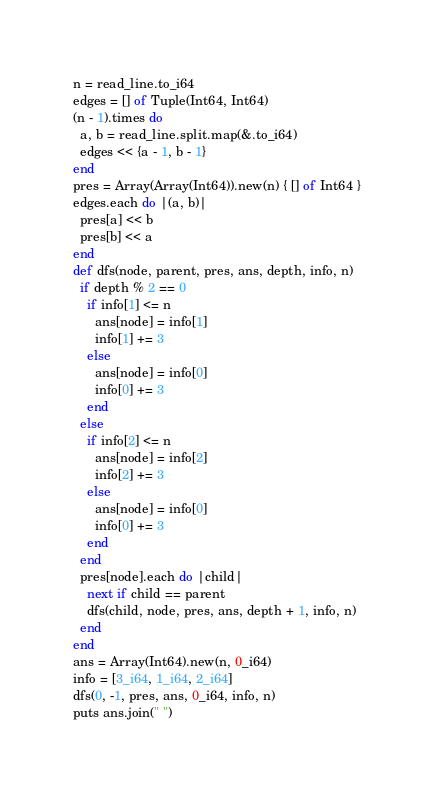Convert code to text. <code><loc_0><loc_0><loc_500><loc_500><_Crystal_>n = read_line.to_i64
edges = [] of Tuple(Int64, Int64)
(n - 1).times do
  a, b = read_line.split.map(&.to_i64)
  edges << {a - 1, b - 1}
end
pres = Array(Array(Int64)).new(n) { [] of Int64 }
edges.each do |(a, b)|
  pres[a] << b
  pres[b] << a
end
def dfs(node, parent, pres, ans, depth, info, n)
  if depth % 2 == 0
    if info[1] <= n
      ans[node] = info[1]
      info[1] += 3
    else
      ans[node] = info[0]
      info[0] += 3
    end
  else
    if info[2] <= n
      ans[node] = info[2]
      info[2] += 3
    else
      ans[node] = info[0]
      info[0] += 3
    end
  end
  pres[node].each do |child|
    next if child == parent
    dfs(child, node, pres, ans, depth + 1, info, n)
  end
end
ans = Array(Int64).new(n, 0_i64)
info = [3_i64, 1_i64, 2_i64]
dfs(0, -1, pres, ans, 0_i64, info, n)
puts ans.join(" ")
</code> 